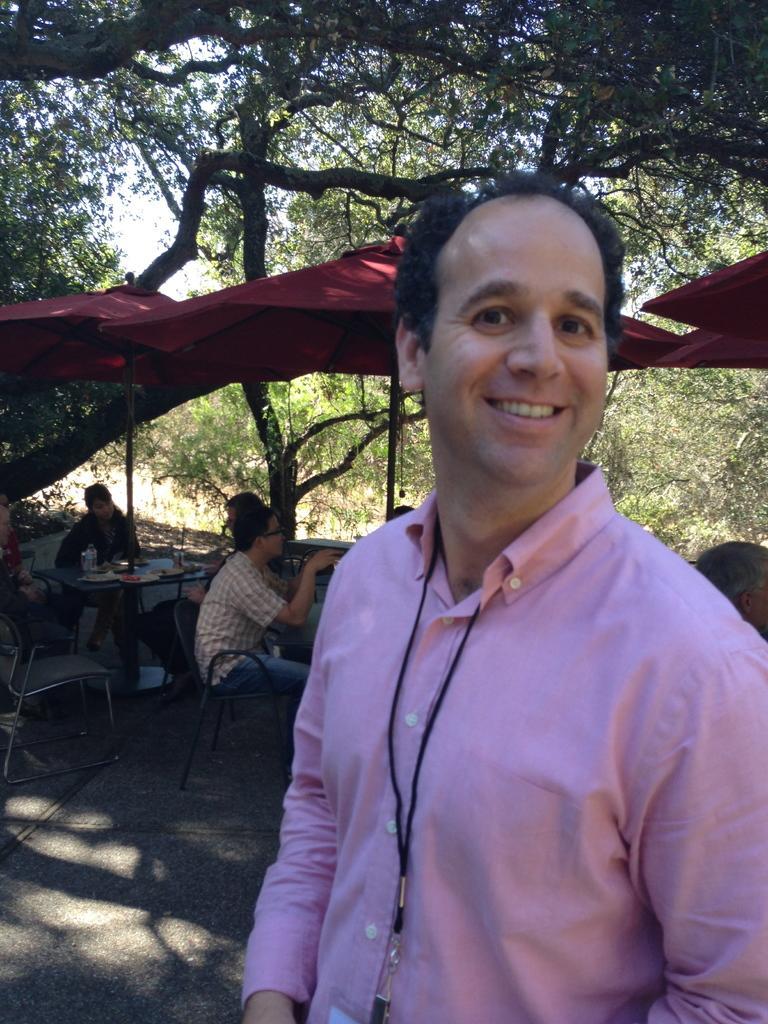How would you summarize this image in a sentence or two? On the right side of the image there is a man standing. Behind him there are few people sitting on the chairs and also there are tables with few items on it. There are umbrellas above them. In the background there are trees. 